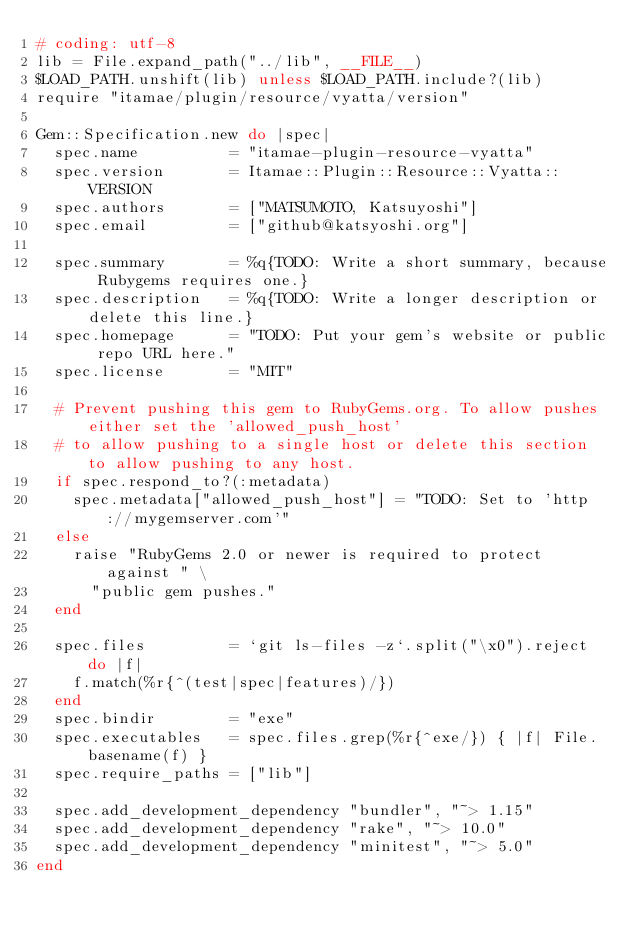<code> <loc_0><loc_0><loc_500><loc_500><_Ruby_># coding: utf-8
lib = File.expand_path("../lib", __FILE__)
$LOAD_PATH.unshift(lib) unless $LOAD_PATH.include?(lib)
require "itamae/plugin/resource/vyatta/version"

Gem::Specification.new do |spec|
  spec.name          = "itamae-plugin-resource-vyatta"
  spec.version       = Itamae::Plugin::Resource::Vyatta::VERSION
  spec.authors       = ["MATSUMOTO, Katsuyoshi"]
  spec.email         = ["github@katsyoshi.org"]

  spec.summary       = %q{TODO: Write a short summary, because Rubygems requires one.}
  spec.description   = %q{TODO: Write a longer description or delete this line.}
  spec.homepage      = "TODO: Put your gem's website or public repo URL here."
  spec.license       = "MIT"

  # Prevent pushing this gem to RubyGems.org. To allow pushes either set the 'allowed_push_host'
  # to allow pushing to a single host or delete this section to allow pushing to any host.
  if spec.respond_to?(:metadata)
    spec.metadata["allowed_push_host"] = "TODO: Set to 'http://mygemserver.com'"
  else
    raise "RubyGems 2.0 or newer is required to protect against " \
      "public gem pushes."
  end

  spec.files         = `git ls-files -z`.split("\x0").reject do |f|
    f.match(%r{^(test|spec|features)/})
  end
  spec.bindir        = "exe"
  spec.executables   = spec.files.grep(%r{^exe/}) { |f| File.basename(f) }
  spec.require_paths = ["lib"]

  spec.add_development_dependency "bundler", "~> 1.15"
  spec.add_development_dependency "rake", "~> 10.0"
  spec.add_development_dependency "minitest", "~> 5.0"
end
</code> 